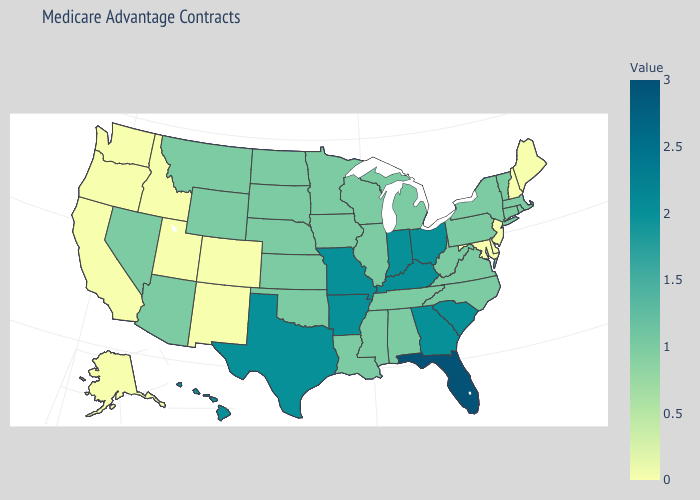Does Mississippi have a lower value than Colorado?
Be succinct. No. Among the states that border Nebraska , does Colorado have the lowest value?
Concise answer only. Yes. Is the legend a continuous bar?
Concise answer only. Yes. Does Florida have the highest value in the USA?
Give a very brief answer. Yes. Among the states that border North Carolina , which have the highest value?
Be succinct. Georgia, South Carolina. Does Nebraska have a higher value than Idaho?
Short answer required. Yes. 